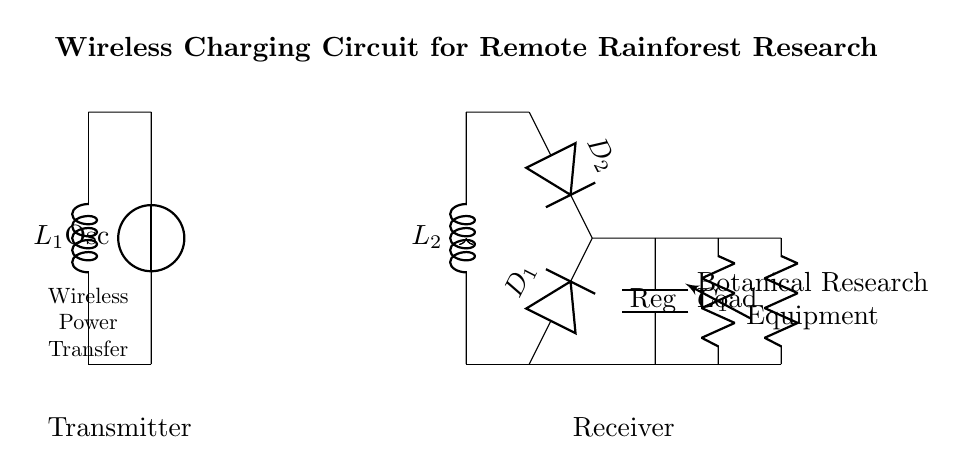What is the function of D1? D1 is a diode that allows current to flow in one direction, enabling the rectification process in the circuit. It converts the alternating current generated in the receiver coil to direct current for the load.
Answer: Diode What component is responsible for energy storage? The component responsible for energy storage in the circuit is the smoothing capacitor (C1). It smooths out the rectified voltage and provides energy to the load when needed.
Answer: Capacitor How many coils are in this circuit? There are two coils in the circuit, L1 (transmitter coil) and L2 (receiver coil), which facilitate wireless power transfer.
Answer: Two What type of voltage source is used in the circuit? The circuit uses a voltage source labeled as "Osc" which likely generates an alternating current of specific frequency for the transmitter coil.
Answer: Oscillator What is connected to the load? The load in the circuit, which represents the botanical research equipment, is connected in series with the voltage regulator to ensure it receives a steady output voltage.
Answer: Equipment Explain the role of the voltage regulator. The voltage regulator ensures that the output voltage provided to the load remains constant despite variations in input voltage or load conditions. It stabilizes the voltage coming out of the smoothing capacitor before it reaches the load.
Answer: Stabilizes voltage What do the arrows between the transmitter and receiver indicate? The arrows represent wireless power transfer, indicating that energy is transferred electromagnetically from the transmitter coil (L1) to the receiver coil (L2) without physical connections.
Answer: Wireless transfer 